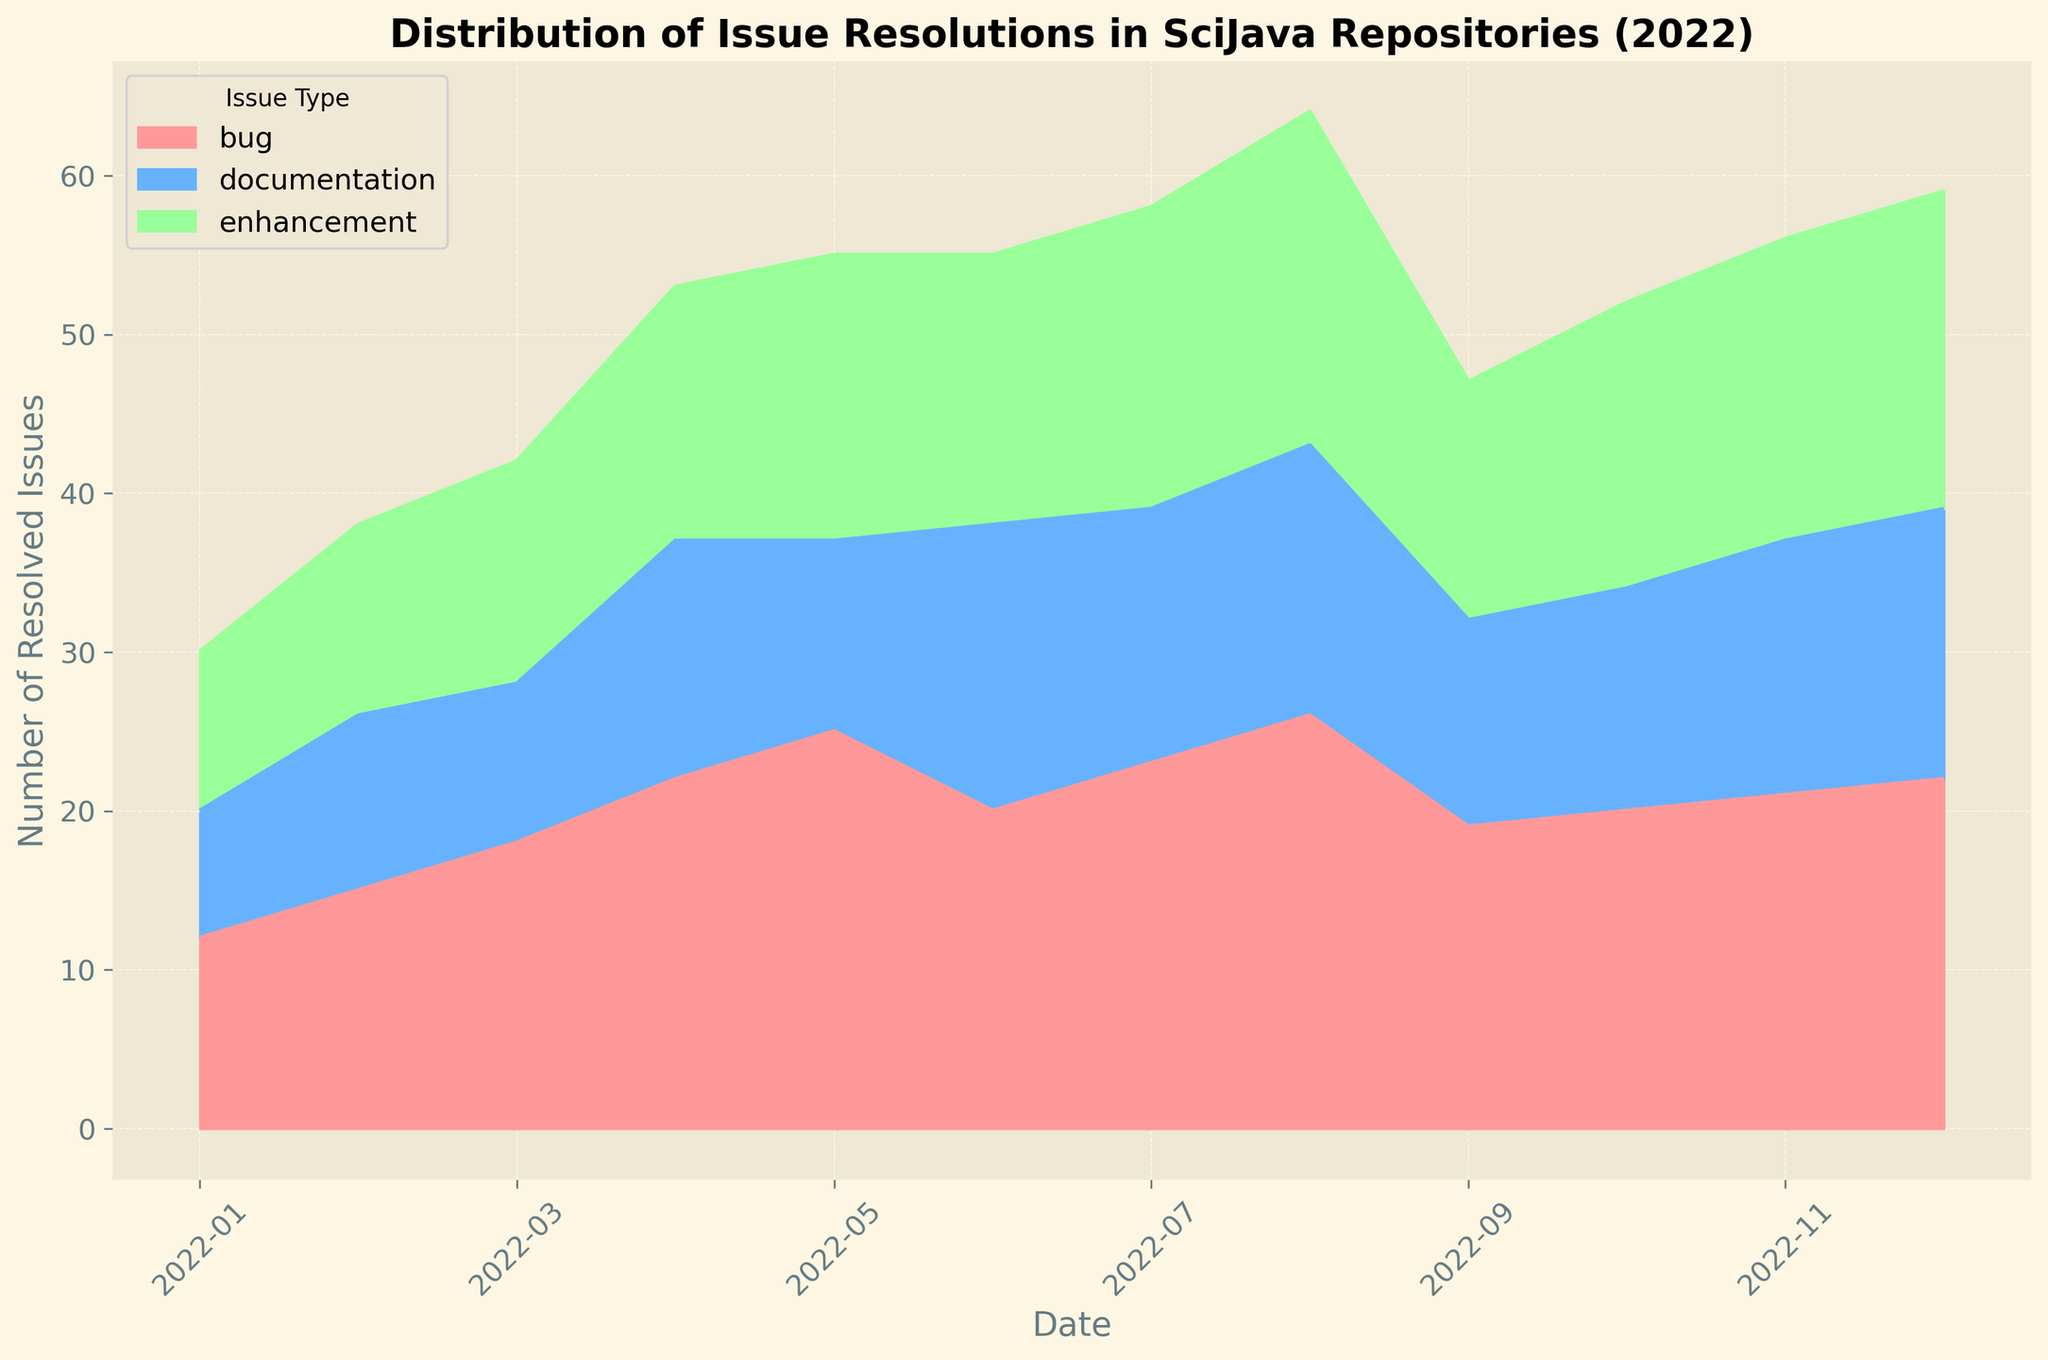What is the overall trend observed for bug resolutions throughout the year? To determine the overall trend for bug resolutions, observe the area corresponding to bugs (usually represented by a distinct color) over the months. The area increases steadily from January to May, then fluctuates slightly but generally remains high. This indicates a steady increase in bug resolutions with minor ups and downs.
Answer: Steady increase with minor fluctuations Which issue type had the highest number of resolutions in August 2022? Look at the height of the area segments at the August mark on the x-axis. Compare the heights of the segments for bugs, enhancements, and documentation. The segment representing bugs is the tallest in August.
Answer: Bugs How many total issues were resolved in December 2022? Sum up the heights of the segments representing all issue types (bugs, enhancements, and documentation) for December. From the data provided: bugs (22) + enhancements (20) + documentation (17) = 59.
Answer: 59 In which month did enhancements see the lowest number of resolutions? Observe the segment representing enhancements across all months. The segment is the shortest in January.
Answer: January Compare the number of documentation issues resolved in June to those resolved in July. Which month had more? Compare the heights of the segments representing documentation issues in June and July. In June, there are 18 resolved documentation issues, while in July, there are 16.
Answer: June Are there any months where the number of enhancements is equal to the number of bugs resolved? Observe the segments for enhancements and bugs across all months and check for equality in height. Both segments are equal in height for November.
Answer: November What is the average number of resolved bugs per month? Sum up the total number of bugs resolved over the year, then divide by 12. From the data provided, the total is 243. Dividing by 12 gives: 243 / 12 = 20.25.
Answer: 20.25 How does the total number of resolved issues in March compare to that in September? Calculate the total resolved issues by summing up all types (bugs, enhancements, documentation) for March and September. March: bugs (18) + enhancements (14) + documentation (10) = 42. September: bugs (19) + enhancements (15) + documentation (13) = 47.
Answer: September has more What is the difference in the number of resolved enhancements between May and October? Subtract the number of resolved enhancements in October from those in May. May has 18, October has 18, so the difference is 0.
Answer: 0 